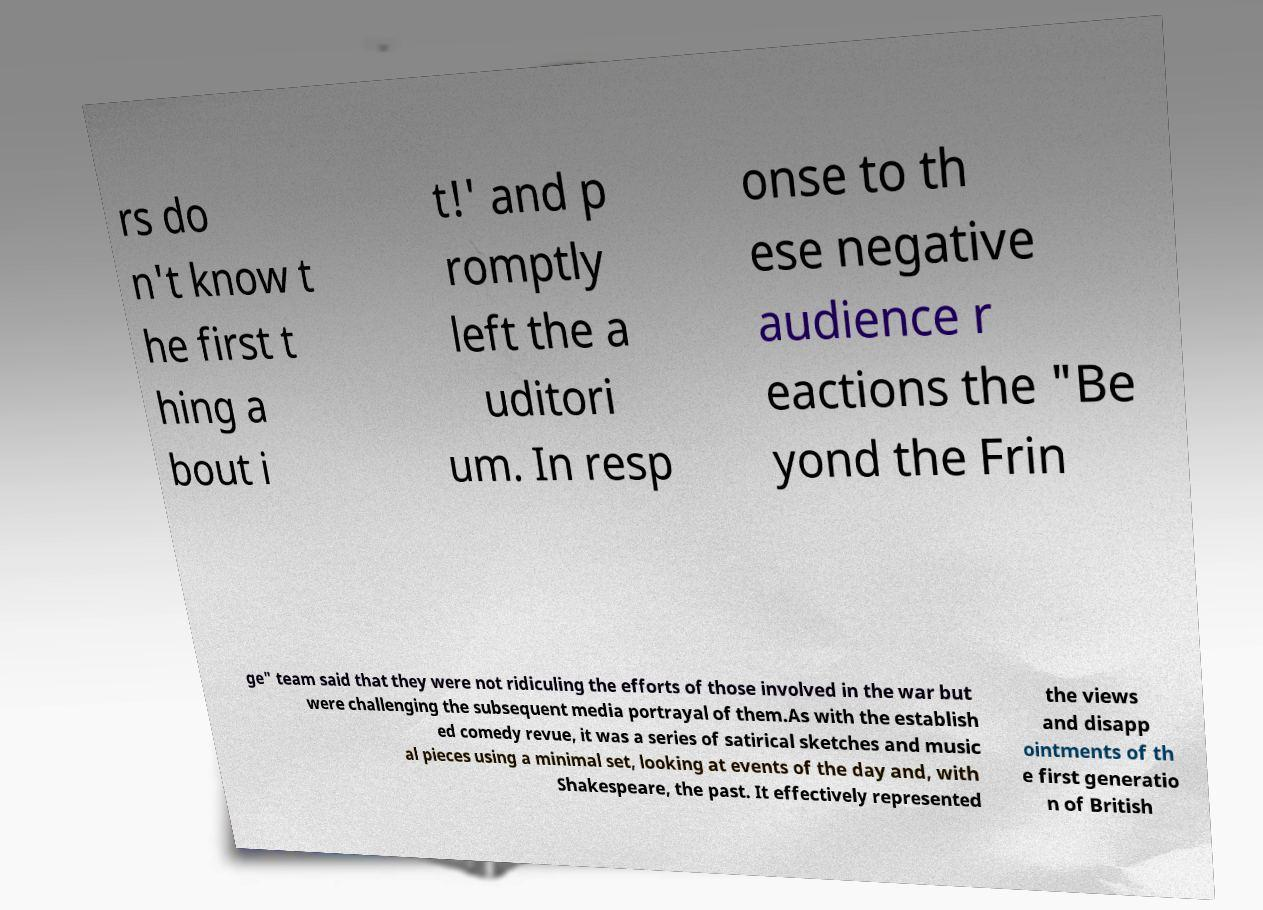For documentation purposes, I need the text within this image transcribed. Could you provide that? rs do n't know t he first t hing a bout i t!' and p romptly left the a uditori um. In resp onse to th ese negative audience r eactions the "Be yond the Frin ge" team said that they were not ridiculing the efforts of those involved in the war but were challenging the subsequent media portrayal of them.As with the establish ed comedy revue, it was a series of satirical sketches and music al pieces using a minimal set, looking at events of the day and, with Shakespeare, the past. It effectively represented the views and disapp ointments of th e first generatio n of British 